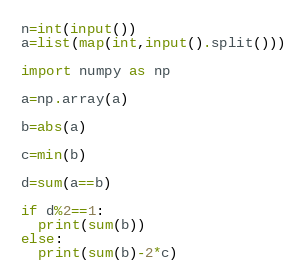<code> <loc_0><loc_0><loc_500><loc_500><_Python_>n=int(input())
a=list(map(int,input().split()))

import numpy as np

a=np.array(a)

b=abs(a)

c=min(b)

d=sum(a==b)

if d%2==1:
  print(sum(b))
else:
  print(sum(b)-2*c)
</code> 